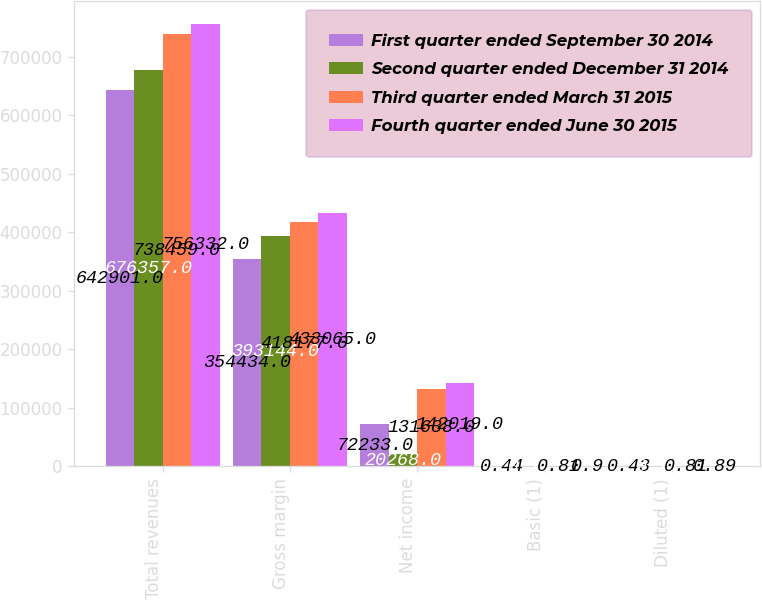Convert chart. <chart><loc_0><loc_0><loc_500><loc_500><stacked_bar_chart><ecel><fcel>Total revenues<fcel>Gross margin<fcel>Net income<fcel>Basic (1)<fcel>Diluted (1)<nl><fcel>First quarter ended September 30 2014<fcel>642901<fcel>354434<fcel>72233<fcel>0.44<fcel>0.43<nl><fcel>Second quarter ended December 31 2014<fcel>676357<fcel>393144<fcel>20268<fcel>0.12<fcel>0.12<nl><fcel>Third quarter ended March 31 2015<fcel>738459<fcel>418177<fcel>131638<fcel>0.81<fcel>0.81<nl><fcel>Fourth quarter ended June 30 2015<fcel>756332<fcel>433065<fcel>142019<fcel>0.9<fcel>0.89<nl></chart> 